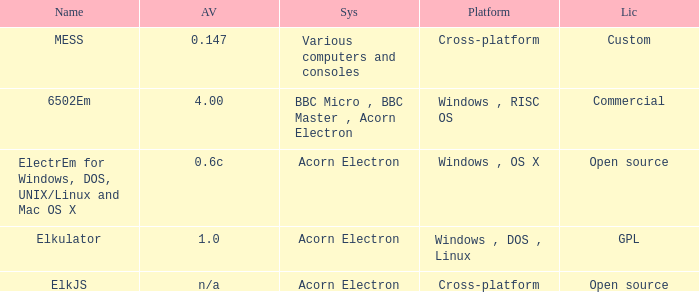What is the system called that is named ELKJS? Acorn Electron. 